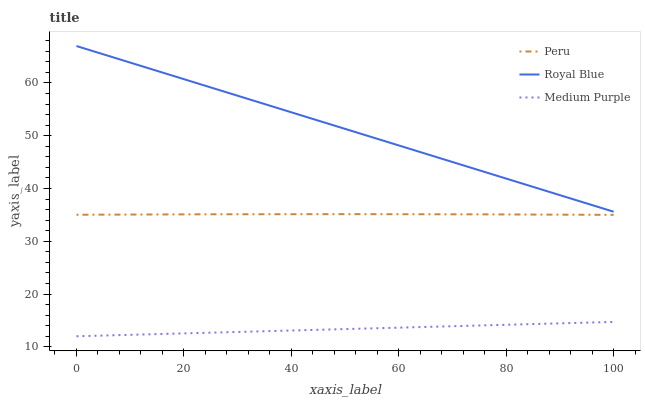Does Medium Purple have the minimum area under the curve?
Answer yes or no. Yes. Does Royal Blue have the maximum area under the curve?
Answer yes or no. Yes. Does Peru have the minimum area under the curve?
Answer yes or no. No. Does Peru have the maximum area under the curve?
Answer yes or no. No. Is Royal Blue the smoothest?
Answer yes or no. Yes. Is Peru the roughest?
Answer yes or no. Yes. Is Peru the smoothest?
Answer yes or no. No. Is Royal Blue the roughest?
Answer yes or no. No. Does Peru have the lowest value?
Answer yes or no. No. Does Peru have the highest value?
Answer yes or no. No. Is Medium Purple less than Royal Blue?
Answer yes or no. Yes. Is Peru greater than Medium Purple?
Answer yes or no. Yes. Does Medium Purple intersect Royal Blue?
Answer yes or no. No. 